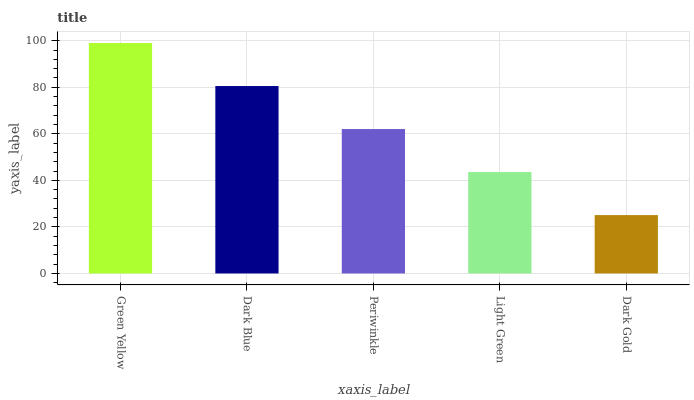Is Dark Gold the minimum?
Answer yes or no. Yes. Is Green Yellow the maximum?
Answer yes or no. Yes. Is Dark Blue the minimum?
Answer yes or no. No. Is Dark Blue the maximum?
Answer yes or no. No. Is Green Yellow greater than Dark Blue?
Answer yes or no. Yes. Is Dark Blue less than Green Yellow?
Answer yes or no. Yes. Is Dark Blue greater than Green Yellow?
Answer yes or no. No. Is Green Yellow less than Dark Blue?
Answer yes or no. No. Is Periwinkle the high median?
Answer yes or no. Yes. Is Periwinkle the low median?
Answer yes or no. Yes. Is Dark Blue the high median?
Answer yes or no. No. Is Dark Blue the low median?
Answer yes or no. No. 